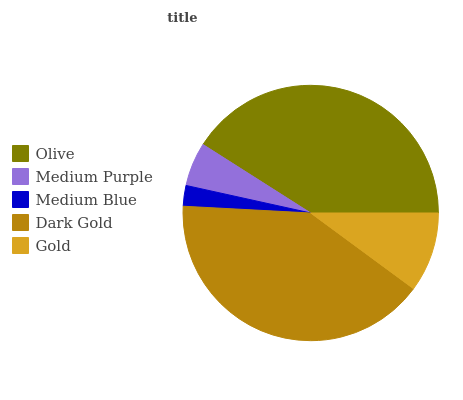Is Medium Blue the minimum?
Answer yes or no. Yes. Is Olive the maximum?
Answer yes or no. Yes. Is Medium Purple the minimum?
Answer yes or no. No. Is Medium Purple the maximum?
Answer yes or no. No. Is Olive greater than Medium Purple?
Answer yes or no. Yes. Is Medium Purple less than Olive?
Answer yes or no. Yes. Is Medium Purple greater than Olive?
Answer yes or no. No. Is Olive less than Medium Purple?
Answer yes or no. No. Is Gold the high median?
Answer yes or no. Yes. Is Gold the low median?
Answer yes or no. Yes. Is Dark Gold the high median?
Answer yes or no. No. Is Olive the low median?
Answer yes or no. No. 